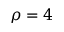<formula> <loc_0><loc_0><loc_500><loc_500>\rho = 4</formula> 